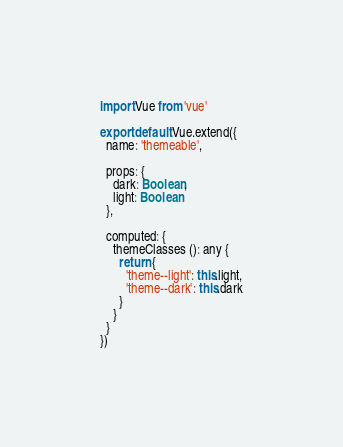<code> <loc_0><loc_0><loc_500><loc_500><_TypeScript_>import Vue from 'vue'

export default Vue.extend({
  name: 'themeable',

  props: {
    dark: Boolean,
    light: Boolean
  },

  computed: {
    themeClasses (): any {
      return {
        'theme--light': this.light,
        'theme--dark': this.dark
      }
    }
  }
})
</code> 